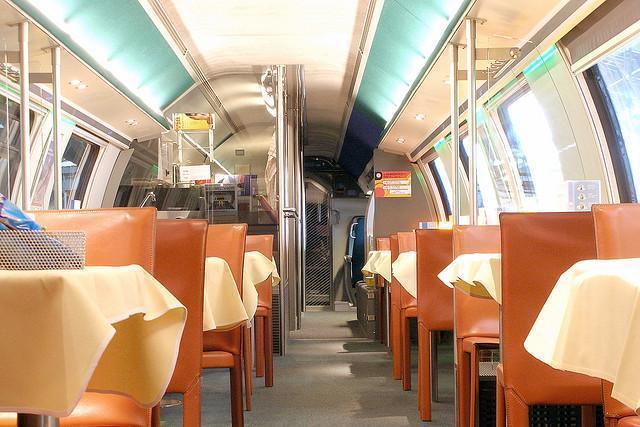Where is this dining room located in all likelihood?
Select the accurate response from the four choices given to answer the question.
Options: Bus, plane, train, storefront. Train. 